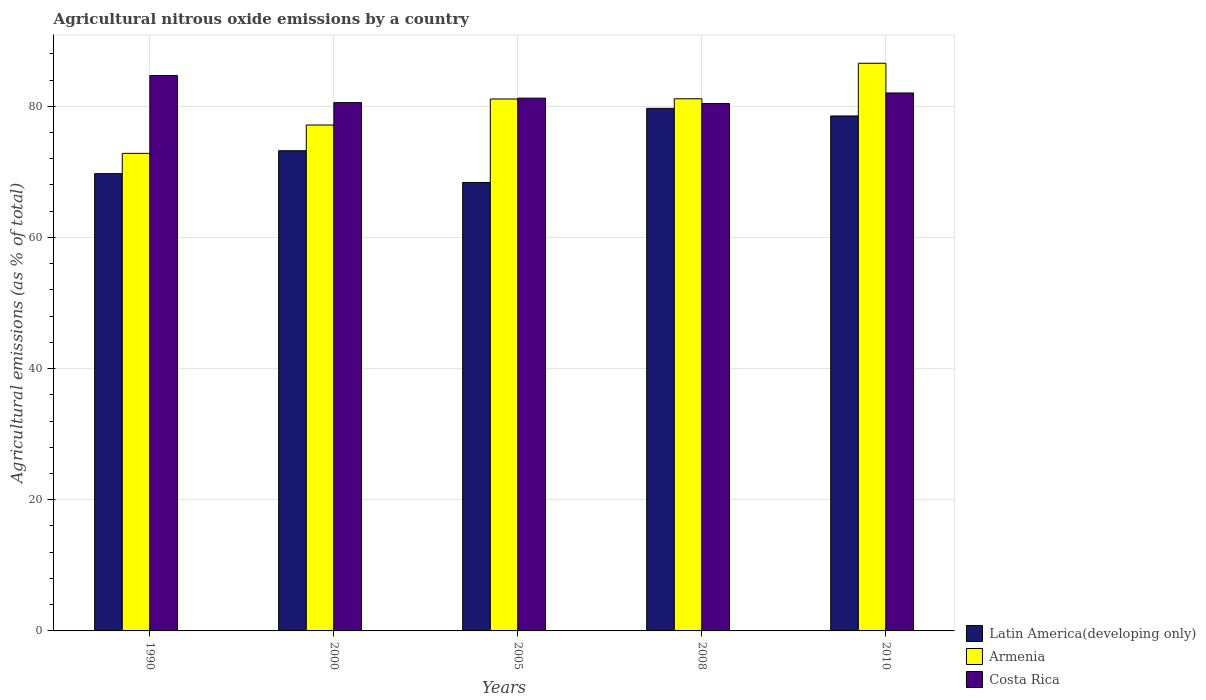How many groups of bars are there?
Offer a terse response. 5. Are the number of bars per tick equal to the number of legend labels?
Give a very brief answer. Yes. How many bars are there on the 4th tick from the left?
Offer a terse response. 3. In how many cases, is the number of bars for a given year not equal to the number of legend labels?
Keep it short and to the point. 0. What is the amount of agricultural nitrous oxide emitted in Latin America(developing only) in 2010?
Make the answer very short. 78.52. Across all years, what is the maximum amount of agricultural nitrous oxide emitted in Latin America(developing only)?
Offer a terse response. 79.68. Across all years, what is the minimum amount of agricultural nitrous oxide emitted in Latin America(developing only)?
Offer a very short reply. 68.38. In which year was the amount of agricultural nitrous oxide emitted in Latin America(developing only) maximum?
Your answer should be compact. 2008. What is the total amount of agricultural nitrous oxide emitted in Costa Rica in the graph?
Keep it short and to the point. 408.93. What is the difference between the amount of agricultural nitrous oxide emitted in Costa Rica in 1990 and that in 2000?
Offer a terse response. 4.13. What is the difference between the amount of agricultural nitrous oxide emitted in Costa Rica in 2000 and the amount of agricultural nitrous oxide emitted in Latin America(developing only) in 2010?
Make the answer very short. 2.04. What is the average amount of agricultural nitrous oxide emitted in Armenia per year?
Ensure brevity in your answer.  79.76. In the year 2010, what is the difference between the amount of agricultural nitrous oxide emitted in Costa Rica and amount of agricultural nitrous oxide emitted in Latin America(developing only)?
Give a very brief answer. 3.51. What is the ratio of the amount of agricultural nitrous oxide emitted in Latin America(developing only) in 1990 to that in 2010?
Offer a terse response. 0.89. What is the difference between the highest and the second highest amount of agricultural nitrous oxide emitted in Costa Rica?
Give a very brief answer. 2.66. What is the difference between the highest and the lowest amount of agricultural nitrous oxide emitted in Costa Rica?
Keep it short and to the point. 4.27. In how many years, is the amount of agricultural nitrous oxide emitted in Armenia greater than the average amount of agricultural nitrous oxide emitted in Armenia taken over all years?
Keep it short and to the point. 3. What does the 1st bar from the left in 2008 represents?
Provide a succinct answer. Latin America(developing only). What does the 3rd bar from the right in 2008 represents?
Provide a short and direct response. Latin America(developing only). How many bars are there?
Provide a short and direct response. 15. Are all the bars in the graph horizontal?
Provide a short and direct response. No. What is the difference between two consecutive major ticks on the Y-axis?
Your answer should be very brief. 20. Are the values on the major ticks of Y-axis written in scientific E-notation?
Your answer should be very brief. No. Does the graph contain grids?
Offer a terse response. Yes. Where does the legend appear in the graph?
Provide a short and direct response. Bottom right. How are the legend labels stacked?
Make the answer very short. Vertical. What is the title of the graph?
Keep it short and to the point. Agricultural nitrous oxide emissions by a country. Does "Sint Maarten (Dutch part)" appear as one of the legend labels in the graph?
Offer a terse response. No. What is the label or title of the X-axis?
Your answer should be compact. Years. What is the label or title of the Y-axis?
Ensure brevity in your answer.  Agricultural emissions (as % of total). What is the Agricultural emissions (as % of total) of Latin America(developing only) in 1990?
Keep it short and to the point. 69.73. What is the Agricultural emissions (as % of total) in Armenia in 1990?
Keep it short and to the point. 72.82. What is the Agricultural emissions (as % of total) of Costa Rica in 1990?
Offer a very short reply. 84.69. What is the Agricultural emissions (as % of total) in Latin America(developing only) in 2000?
Ensure brevity in your answer.  73.22. What is the Agricultural emissions (as % of total) of Armenia in 2000?
Your response must be concise. 77.14. What is the Agricultural emissions (as % of total) in Costa Rica in 2000?
Give a very brief answer. 80.56. What is the Agricultural emissions (as % of total) in Latin America(developing only) in 2005?
Give a very brief answer. 68.38. What is the Agricultural emissions (as % of total) of Armenia in 2005?
Provide a short and direct response. 81.11. What is the Agricultural emissions (as % of total) in Costa Rica in 2005?
Ensure brevity in your answer.  81.24. What is the Agricultural emissions (as % of total) in Latin America(developing only) in 2008?
Make the answer very short. 79.68. What is the Agricultural emissions (as % of total) of Armenia in 2008?
Provide a short and direct response. 81.15. What is the Agricultural emissions (as % of total) in Costa Rica in 2008?
Offer a terse response. 80.42. What is the Agricultural emissions (as % of total) of Latin America(developing only) in 2010?
Ensure brevity in your answer.  78.52. What is the Agricultural emissions (as % of total) of Armenia in 2010?
Offer a terse response. 86.56. What is the Agricultural emissions (as % of total) in Costa Rica in 2010?
Give a very brief answer. 82.03. Across all years, what is the maximum Agricultural emissions (as % of total) of Latin America(developing only)?
Provide a short and direct response. 79.68. Across all years, what is the maximum Agricultural emissions (as % of total) of Armenia?
Your response must be concise. 86.56. Across all years, what is the maximum Agricultural emissions (as % of total) of Costa Rica?
Ensure brevity in your answer.  84.69. Across all years, what is the minimum Agricultural emissions (as % of total) in Latin America(developing only)?
Make the answer very short. 68.38. Across all years, what is the minimum Agricultural emissions (as % of total) in Armenia?
Your answer should be very brief. 72.82. Across all years, what is the minimum Agricultural emissions (as % of total) of Costa Rica?
Keep it short and to the point. 80.42. What is the total Agricultural emissions (as % of total) of Latin America(developing only) in the graph?
Offer a very short reply. 369.54. What is the total Agricultural emissions (as % of total) of Armenia in the graph?
Provide a short and direct response. 398.78. What is the total Agricultural emissions (as % of total) of Costa Rica in the graph?
Offer a terse response. 408.93. What is the difference between the Agricultural emissions (as % of total) of Latin America(developing only) in 1990 and that in 2000?
Give a very brief answer. -3.49. What is the difference between the Agricultural emissions (as % of total) of Armenia in 1990 and that in 2000?
Your answer should be compact. -4.32. What is the difference between the Agricultural emissions (as % of total) of Costa Rica in 1990 and that in 2000?
Ensure brevity in your answer.  4.13. What is the difference between the Agricultural emissions (as % of total) of Latin America(developing only) in 1990 and that in 2005?
Your response must be concise. 1.35. What is the difference between the Agricultural emissions (as % of total) of Armenia in 1990 and that in 2005?
Your answer should be very brief. -8.29. What is the difference between the Agricultural emissions (as % of total) of Costa Rica in 1990 and that in 2005?
Offer a terse response. 3.45. What is the difference between the Agricultural emissions (as % of total) of Latin America(developing only) in 1990 and that in 2008?
Provide a short and direct response. -9.95. What is the difference between the Agricultural emissions (as % of total) in Armenia in 1990 and that in 2008?
Offer a very short reply. -8.33. What is the difference between the Agricultural emissions (as % of total) of Costa Rica in 1990 and that in 2008?
Ensure brevity in your answer.  4.27. What is the difference between the Agricultural emissions (as % of total) of Latin America(developing only) in 1990 and that in 2010?
Provide a short and direct response. -8.79. What is the difference between the Agricultural emissions (as % of total) in Armenia in 1990 and that in 2010?
Your answer should be very brief. -13.74. What is the difference between the Agricultural emissions (as % of total) in Costa Rica in 1990 and that in 2010?
Give a very brief answer. 2.66. What is the difference between the Agricultural emissions (as % of total) in Latin America(developing only) in 2000 and that in 2005?
Offer a terse response. 4.84. What is the difference between the Agricultural emissions (as % of total) of Armenia in 2000 and that in 2005?
Give a very brief answer. -3.97. What is the difference between the Agricultural emissions (as % of total) in Costa Rica in 2000 and that in 2005?
Give a very brief answer. -0.68. What is the difference between the Agricultural emissions (as % of total) of Latin America(developing only) in 2000 and that in 2008?
Keep it short and to the point. -6.46. What is the difference between the Agricultural emissions (as % of total) of Armenia in 2000 and that in 2008?
Offer a terse response. -4. What is the difference between the Agricultural emissions (as % of total) in Costa Rica in 2000 and that in 2008?
Offer a terse response. 0.14. What is the difference between the Agricultural emissions (as % of total) in Latin America(developing only) in 2000 and that in 2010?
Your response must be concise. -5.3. What is the difference between the Agricultural emissions (as % of total) of Armenia in 2000 and that in 2010?
Keep it short and to the point. -9.42. What is the difference between the Agricultural emissions (as % of total) of Costa Rica in 2000 and that in 2010?
Give a very brief answer. -1.47. What is the difference between the Agricultural emissions (as % of total) of Latin America(developing only) in 2005 and that in 2008?
Give a very brief answer. -11.3. What is the difference between the Agricultural emissions (as % of total) in Armenia in 2005 and that in 2008?
Offer a very short reply. -0.03. What is the difference between the Agricultural emissions (as % of total) of Costa Rica in 2005 and that in 2008?
Keep it short and to the point. 0.83. What is the difference between the Agricultural emissions (as % of total) in Latin America(developing only) in 2005 and that in 2010?
Give a very brief answer. -10.14. What is the difference between the Agricultural emissions (as % of total) of Armenia in 2005 and that in 2010?
Offer a very short reply. -5.45. What is the difference between the Agricultural emissions (as % of total) in Costa Rica in 2005 and that in 2010?
Make the answer very short. -0.79. What is the difference between the Agricultural emissions (as % of total) of Latin America(developing only) in 2008 and that in 2010?
Your answer should be very brief. 1.16. What is the difference between the Agricultural emissions (as % of total) of Armenia in 2008 and that in 2010?
Offer a terse response. -5.41. What is the difference between the Agricultural emissions (as % of total) of Costa Rica in 2008 and that in 2010?
Provide a short and direct response. -1.61. What is the difference between the Agricultural emissions (as % of total) in Latin America(developing only) in 1990 and the Agricultural emissions (as % of total) in Armenia in 2000?
Your answer should be very brief. -7.42. What is the difference between the Agricultural emissions (as % of total) of Latin America(developing only) in 1990 and the Agricultural emissions (as % of total) of Costa Rica in 2000?
Keep it short and to the point. -10.83. What is the difference between the Agricultural emissions (as % of total) in Armenia in 1990 and the Agricultural emissions (as % of total) in Costa Rica in 2000?
Ensure brevity in your answer.  -7.74. What is the difference between the Agricultural emissions (as % of total) of Latin America(developing only) in 1990 and the Agricultural emissions (as % of total) of Armenia in 2005?
Offer a terse response. -11.38. What is the difference between the Agricultural emissions (as % of total) in Latin America(developing only) in 1990 and the Agricultural emissions (as % of total) in Costa Rica in 2005?
Offer a terse response. -11.51. What is the difference between the Agricultural emissions (as % of total) in Armenia in 1990 and the Agricultural emissions (as % of total) in Costa Rica in 2005?
Offer a very short reply. -8.42. What is the difference between the Agricultural emissions (as % of total) of Latin America(developing only) in 1990 and the Agricultural emissions (as % of total) of Armenia in 2008?
Give a very brief answer. -11.42. What is the difference between the Agricultural emissions (as % of total) of Latin America(developing only) in 1990 and the Agricultural emissions (as % of total) of Costa Rica in 2008?
Your response must be concise. -10.69. What is the difference between the Agricultural emissions (as % of total) in Armenia in 1990 and the Agricultural emissions (as % of total) in Costa Rica in 2008?
Ensure brevity in your answer.  -7.6. What is the difference between the Agricultural emissions (as % of total) in Latin America(developing only) in 1990 and the Agricultural emissions (as % of total) in Armenia in 2010?
Provide a short and direct response. -16.83. What is the difference between the Agricultural emissions (as % of total) of Latin America(developing only) in 1990 and the Agricultural emissions (as % of total) of Costa Rica in 2010?
Keep it short and to the point. -12.3. What is the difference between the Agricultural emissions (as % of total) in Armenia in 1990 and the Agricultural emissions (as % of total) in Costa Rica in 2010?
Your response must be concise. -9.21. What is the difference between the Agricultural emissions (as % of total) in Latin America(developing only) in 2000 and the Agricultural emissions (as % of total) in Armenia in 2005?
Your response must be concise. -7.89. What is the difference between the Agricultural emissions (as % of total) in Latin America(developing only) in 2000 and the Agricultural emissions (as % of total) in Costa Rica in 2005?
Keep it short and to the point. -8.02. What is the difference between the Agricultural emissions (as % of total) in Armenia in 2000 and the Agricultural emissions (as % of total) in Costa Rica in 2005?
Offer a very short reply. -4.1. What is the difference between the Agricultural emissions (as % of total) in Latin America(developing only) in 2000 and the Agricultural emissions (as % of total) in Armenia in 2008?
Provide a succinct answer. -7.92. What is the difference between the Agricultural emissions (as % of total) in Latin America(developing only) in 2000 and the Agricultural emissions (as % of total) in Costa Rica in 2008?
Make the answer very short. -7.19. What is the difference between the Agricultural emissions (as % of total) in Armenia in 2000 and the Agricultural emissions (as % of total) in Costa Rica in 2008?
Provide a short and direct response. -3.27. What is the difference between the Agricultural emissions (as % of total) in Latin America(developing only) in 2000 and the Agricultural emissions (as % of total) in Armenia in 2010?
Make the answer very short. -13.34. What is the difference between the Agricultural emissions (as % of total) of Latin America(developing only) in 2000 and the Agricultural emissions (as % of total) of Costa Rica in 2010?
Offer a very short reply. -8.81. What is the difference between the Agricultural emissions (as % of total) in Armenia in 2000 and the Agricultural emissions (as % of total) in Costa Rica in 2010?
Provide a short and direct response. -4.88. What is the difference between the Agricultural emissions (as % of total) of Latin America(developing only) in 2005 and the Agricultural emissions (as % of total) of Armenia in 2008?
Offer a terse response. -12.76. What is the difference between the Agricultural emissions (as % of total) in Latin America(developing only) in 2005 and the Agricultural emissions (as % of total) in Costa Rica in 2008?
Provide a succinct answer. -12.03. What is the difference between the Agricultural emissions (as % of total) in Armenia in 2005 and the Agricultural emissions (as % of total) in Costa Rica in 2008?
Your answer should be very brief. 0.7. What is the difference between the Agricultural emissions (as % of total) of Latin America(developing only) in 2005 and the Agricultural emissions (as % of total) of Armenia in 2010?
Offer a very short reply. -18.18. What is the difference between the Agricultural emissions (as % of total) of Latin America(developing only) in 2005 and the Agricultural emissions (as % of total) of Costa Rica in 2010?
Provide a short and direct response. -13.65. What is the difference between the Agricultural emissions (as % of total) in Armenia in 2005 and the Agricultural emissions (as % of total) in Costa Rica in 2010?
Give a very brief answer. -0.91. What is the difference between the Agricultural emissions (as % of total) of Latin America(developing only) in 2008 and the Agricultural emissions (as % of total) of Armenia in 2010?
Offer a terse response. -6.88. What is the difference between the Agricultural emissions (as % of total) in Latin America(developing only) in 2008 and the Agricultural emissions (as % of total) in Costa Rica in 2010?
Offer a terse response. -2.35. What is the difference between the Agricultural emissions (as % of total) in Armenia in 2008 and the Agricultural emissions (as % of total) in Costa Rica in 2010?
Ensure brevity in your answer.  -0.88. What is the average Agricultural emissions (as % of total) of Latin America(developing only) per year?
Make the answer very short. 73.91. What is the average Agricultural emissions (as % of total) of Armenia per year?
Provide a short and direct response. 79.76. What is the average Agricultural emissions (as % of total) in Costa Rica per year?
Provide a short and direct response. 81.79. In the year 1990, what is the difference between the Agricultural emissions (as % of total) in Latin America(developing only) and Agricultural emissions (as % of total) in Armenia?
Provide a short and direct response. -3.09. In the year 1990, what is the difference between the Agricultural emissions (as % of total) of Latin America(developing only) and Agricultural emissions (as % of total) of Costa Rica?
Give a very brief answer. -14.96. In the year 1990, what is the difference between the Agricultural emissions (as % of total) in Armenia and Agricultural emissions (as % of total) in Costa Rica?
Make the answer very short. -11.87. In the year 2000, what is the difference between the Agricultural emissions (as % of total) in Latin America(developing only) and Agricultural emissions (as % of total) in Armenia?
Your answer should be compact. -3.92. In the year 2000, what is the difference between the Agricultural emissions (as % of total) in Latin America(developing only) and Agricultural emissions (as % of total) in Costa Rica?
Give a very brief answer. -7.34. In the year 2000, what is the difference between the Agricultural emissions (as % of total) in Armenia and Agricultural emissions (as % of total) in Costa Rica?
Keep it short and to the point. -3.41. In the year 2005, what is the difference between the Agricultural emissions (as % of total) of Latin America(developing only) and Agricultural emissions (as % of total) of Armenia?
Your answer should be compact. -12.73. In the year 2005, what is the difference between the Agricultural emissions (as % of total) in Latin America(developing only) and Agricultural emissions (as % of total) in Costa Rica?
Provide a succinct answer. -12.86. In the year 2005, what is the difference between the Agricultural emissions (as % of total) of Armenia and Agricultural emissions (as % of total) of Costa Rica?
Your response must be concise. -0.13. In the year 2008, what is the difference between the Agricultural emissions (as % of total) of Latin America(developing only) and Agricultural emissions (as % of total) of Armenia?
Your answer should be very brief. -1.47. In the year 2008, what is the difference between the Agricultural emissions (as % of total) of Latin America(developing only) and Agricultural emissions (as % of total) of Costa Rica?
Offer a very short reply. -0.74. In the year 2008, what is the difference between the Agricultural emissions (as % of total) of Armenia and Agricultural emissions (as % of total) of Costa Rica?
Your answer should be very brief. 0.73. In the year 2010, what is the difference between the Agricultural emissions (as % of total) of Latin America(developing only) and Agricultural emissions (as % of total) of Armenia?
Offer a very short reply. -8.04. In the year 2010, what is the difference between the Agricultural emissions (as % of total) of Latin America(developing only) and Agricultural emissions (as % of total) of Costa Rica?
Ensure brevity in your answer.  -3.51. In the year 2010, what is the difference between the Agricultural emissions (as % of total) in Armenia and Agricultural emissions (as % of total) in Costa Rica?
Offer a terse response. 4.53. What is the ratio of the Agricultural emissions (as % of total) in Latin America(developing only) in 1990 to that in 2000?
Give a very brief answer. 0.95. What is the ratio of the Agricultural emissions (as % of total) in Armenia in 1990 to that in 2000?
Keep it short and to the point. 0.94. What is the ratio of the Agricultural emissions (as % of total) of Costa Rica in 1990 to that in 2000?
Your response must be concise. 1.05. What is the ratio of the Agricultural emissions (as % of total) of Latin America(developing only) in 1990 to that in 2005?
Provide a short and direct response. 1.02. What is the ratio of the Agricultural emissions (as % of total) of Armenia in 1990 to that in 2005?
Provide a short and direct response. 0.9. What is the ratio of the Agricultural emissions (as % of total) of Costa Rica in 1990 to that in 2005?
Your answer should be very brief. 1.04. What is the ratio of the Agricultural emissions (as % of total) of Latin America(developing only) in 1990 to that in 2008?
Offer a terse response. 0.88. What is the ratio of the Agricultural emissions (as % of total) of Armenia in 1990 to that in 2008?
Offer a very short reply. 0.9. What is the ratio of the Agricultural emissions (as % of total) in Costa Rica in 1990 to that in 2008?
Offer a terse response. 1.05. What is the ratio of the Agricultural emissions (as % of total) of Latin America(developing only) in 1990 to that in 2010?
Offer a very short reply. 0.89. What is the ratio of the Agricultural emissions (as % of total) of Armenia in 1990 to that in 2010?
Give a very brief answer. 0.84. What is the ratio of the Agricultural emissions (as % of total) of Costa Rica in 1990 to that in 2010?
Offer a very short reply. 1.03. What is the ratio of the Agricultural emissions (as % of total) in Latin America(developing only) in 2000 to that in 2005?
Provide a succinct answer. 1.07. What is the ratio of the Agricultural emissions (as % of total) of Armenia in 2000 to that in 2005?
Your answer should be very brief. 0.95. What is the ratio of the Agricultural emissions (as % of total) of Costa Rica in 2000 to that in 2005?
Ensure brevity in your answer.  0.99. What is the ratio of the Agricultural emissions (as % of total) in Latin America(developing only) in 2000 to that in 2008?
Keep it short and to the point. 0.92. What is the ratio of the Agricultural emissions (as % of total) of Armenia in 2000 to that in 2008?
Ensure brevity in your answer.  0.95. What is the ratio of the Agricultural emissions (as % of total) of Latin America(developing only) in 2000 to that in 2010?
Your answer should be compact. 0.93. What is the ratio of the Agricultural emissions (as % of total) of Armenia in 2000 to that in 2010?
Provide a succinct answer. 0.89. What is the ratio of the Agricultural emissions (as % of total) of Costa Rica in 2000 to that in 2010?
Offer a terse response. 0.98. What is the ratio of the Agricultural emissions (as % of total) of Latin America(developing only) in 2005 to that in 2008?
Give a very brief answer. 0.86. What is the ratio of the Agricultural emissions (as % of total) in Costa Rica in 2005 to that in 2008?
Provide a short and direct response. 1.01. What is the ratio of the Agricultural emissions (as % of total) in Latin America(developing only) in 2005 to that in 2010?
Ensure brevity in your answer.  0.87. What is the ratio of the Agricultural emissions (as % of total) in Armenia in 2005 to that in 2010?
Provide a succinct answer. 0.94. What is the ratio of the Agricultural emissions (as % of total) in Latin America(developing only) in 2008 to that in 2010?
Offer a very short reply. 1.01. What is the ratio of the Agricultural emissions (as % of total) of Armenia in 2008 to that in 2010?
Your answer should be very brief. 0.94. What is the ratio of the Agricultural emissions (as % of total) of Costa Rica in 2008 to that in 2010?
Offer a very short reply. 0.98. What is the difference between the highest and the second highest Agricultural emissions (as % of total) in Latin America(developing only)?
Provide a succinct answer. 1.16. What is the difference between the highest and the second highest Agricultural emissions (as % of total) in Armenia?
Offer a terse response. 5.41. What is the difference between the highest and the second highest Agricultural emissions (as % of total) of Costa Rica?
Offer a very short reply. 2.66. What is the difference between the highest and the lowest Agricultural emissions (as % of total) in Latin America(developing only)?
Ensure brevity in your answer.  11.3. What is the difference between the highest and the lowest Agricultural emissions (as % of total) of Armenia?
Offer a terse response. 13.74. What is the difference between the highest and the lowest Agricultural emissions (as % of total) of Costa Rica?
Your answer should be compact. 4.27. 